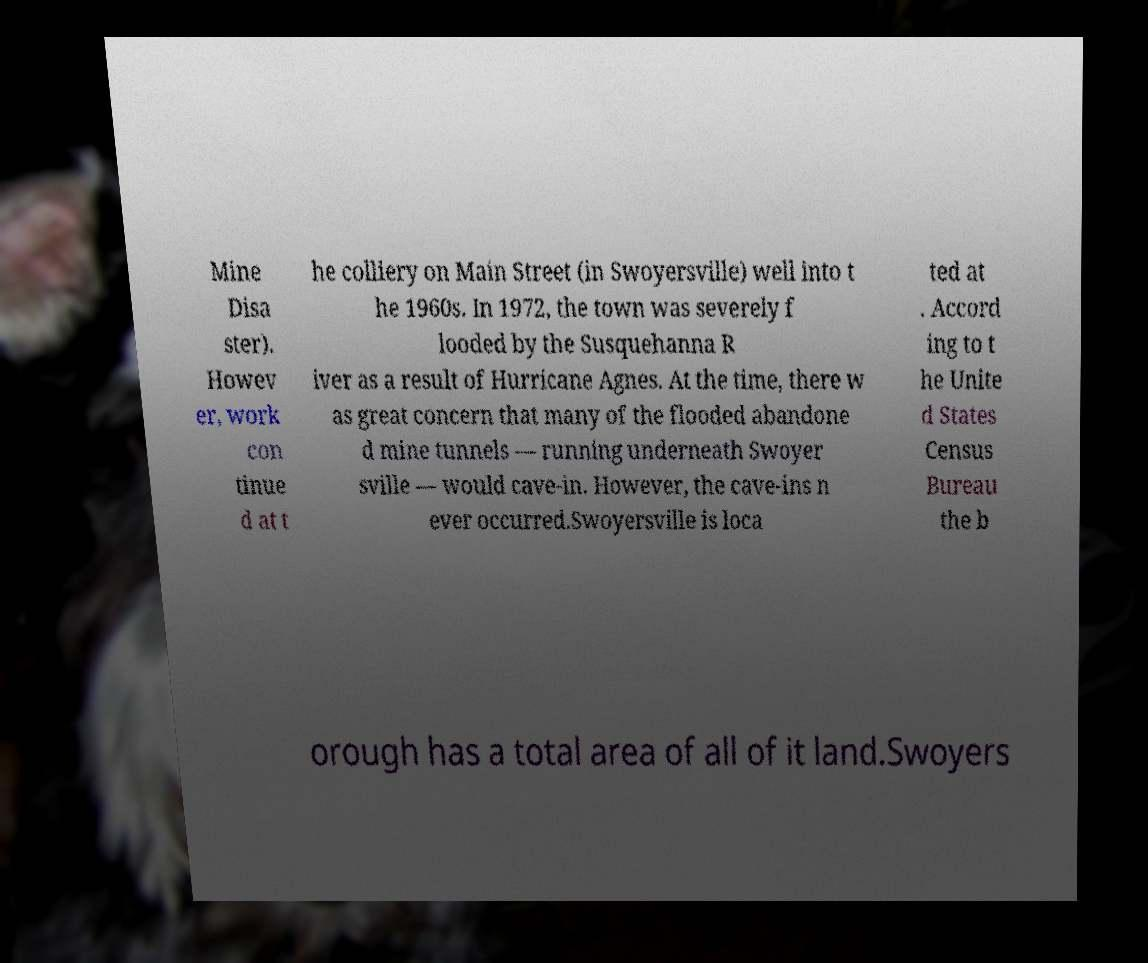Can you read and provide the text displayed in the image?This photo seems to have some interesting text. Can you extract and type it out for me? Mine Disa ster). Howev er, work con tinue d at t he colliery on Main Street (in Swoyersville) well into t he 1960s. In 1972, the town was severely f looded by the Susquehanna R iver as a result of Hurricane Agnes. At the time, there w as great concern that many of the flooded abandone d mine tunnels — running underneath Swoyer sville — would cave-in. However, the cave-ins n ever occurred.Swoyersville is loca ted at . Accord ing to t he Unite d States Census Bureau the b orough has a total area of all of it land.Swoyers 